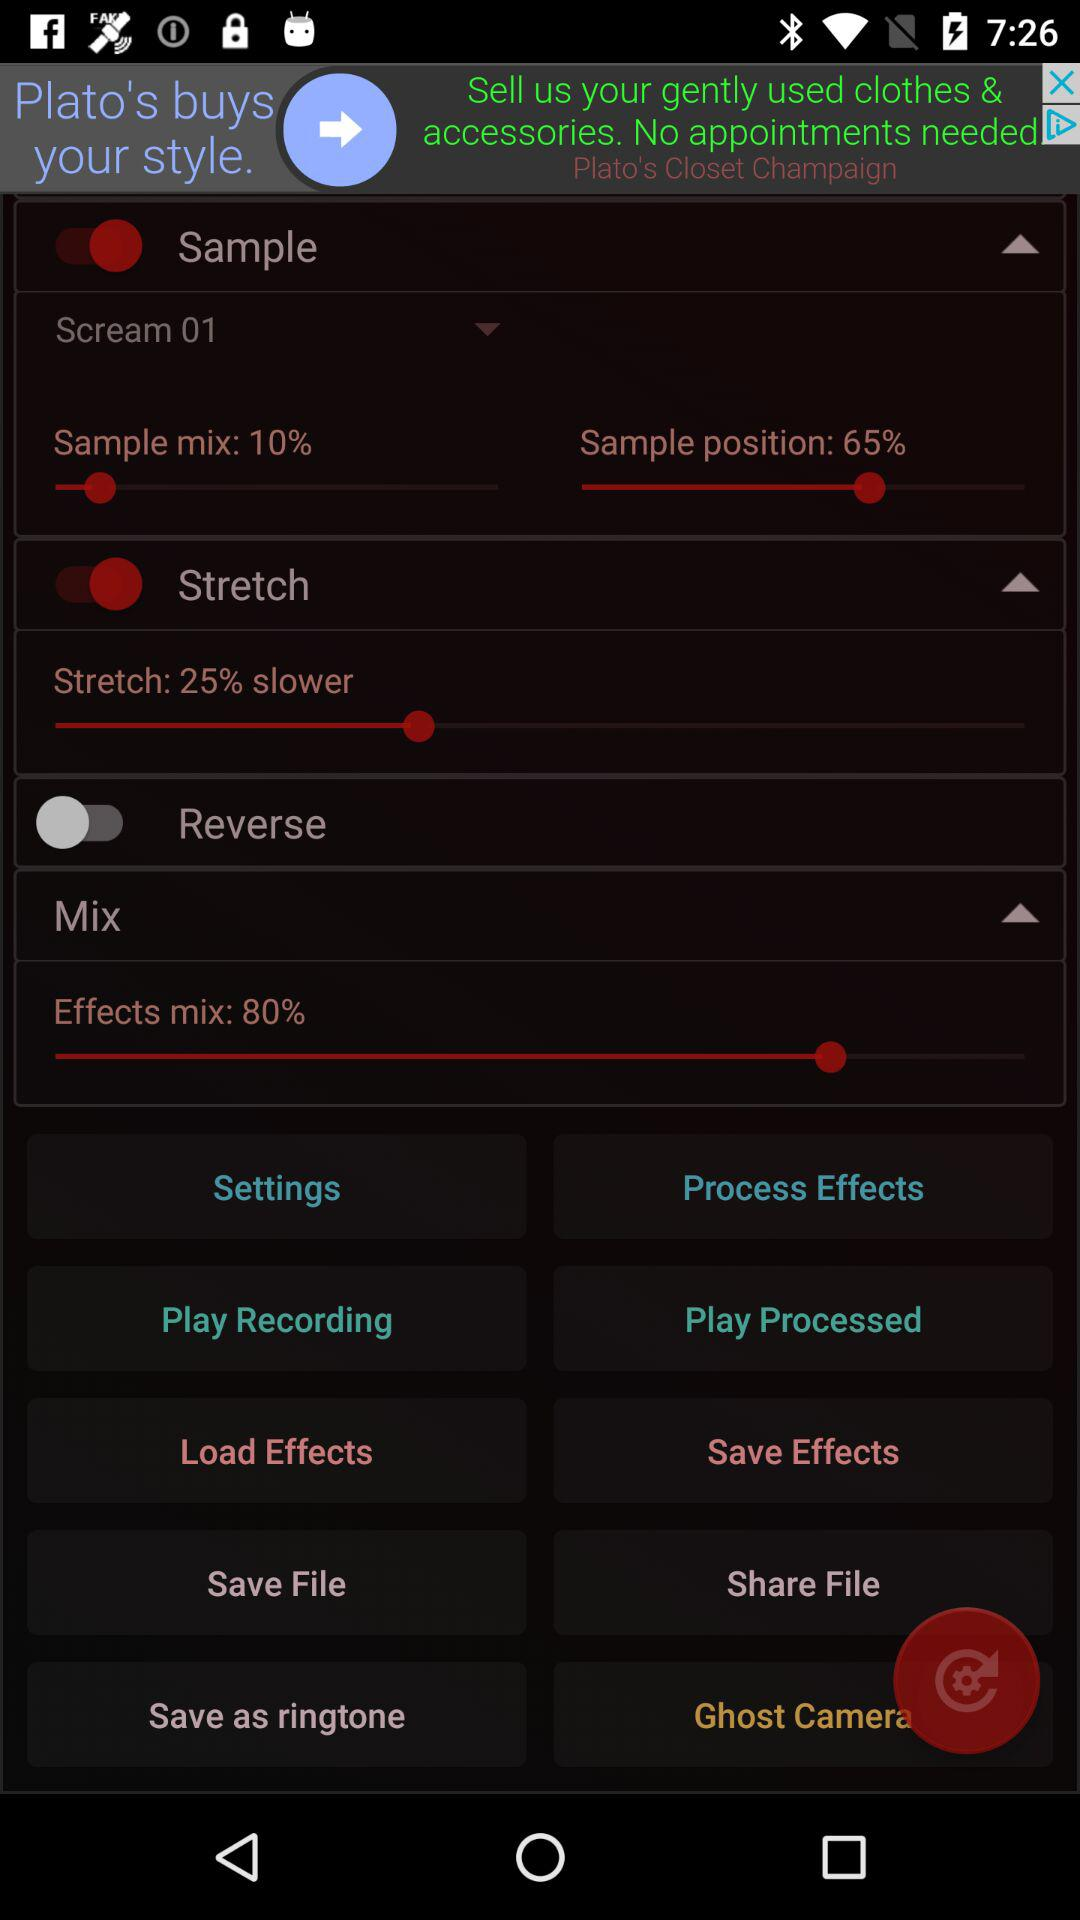How many switches are on the page?
Answer the question using a single word or phrase. 3 